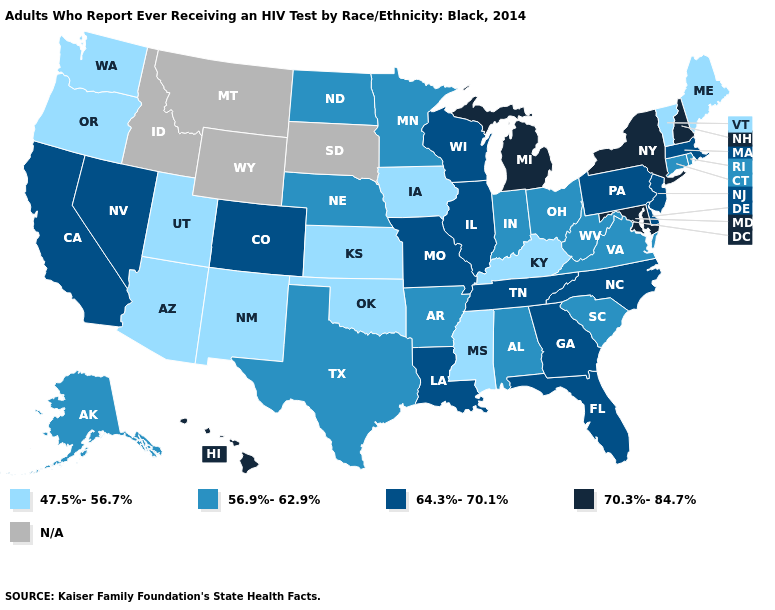Which states hav the highest value in the MidWest?
Quick response, please. Michigan. What is the value of Michigan?
Be succinct. 70.3%-84.7%. What is the value of Colorado?
Be succinct. 64.3%-70.1%. Which states have the lowest value in the South?
Give a very brief answer. Kentucky, Mississippi, Oklahoma. What is the value of New Mexico?
Give a very brief answer. 47.5%-56.7%. Name the states that have a value in the range 56.9%-62.9%?
Be succinct. Alabama, Alaska, Arkansas, Connecticut, Indiana, Minnesota, Nebraska, North Dakota, Ohio, Rhode Island, South Carolina, Texas, Virginia, West Virginia. What is the value of North Carolina?
Quick response, please. 64.3%-70.1%. Name the states that have a value in the range 47.5%-56.7%?
Quick response, please. Arizona, Iowa, Kansas, Kentucky, Maine, Mississippi, New Mexico, Oklahoma, Oregon, Utah, Vermont, Washington. What is the value of Wisconsin?
Give a very brief answer. 64.3%-70.1%. Among the states that border Arizona , does Nevada have the highest value?
Keep it brief. Yes. What is the lowest value in states that border Georgia?
Answer briefly. 56.9%-62.9%. Does Alaska have the lowest value in the West?
Concise answer only. No. Name the states that have a value in the range 70.3%-84.7%?
Be succinct. Hawaii, Maryland, Michigan, New Hampshire, New York. What is the value of Alaska?
Answer briefly. 56.9%-62.9%. 